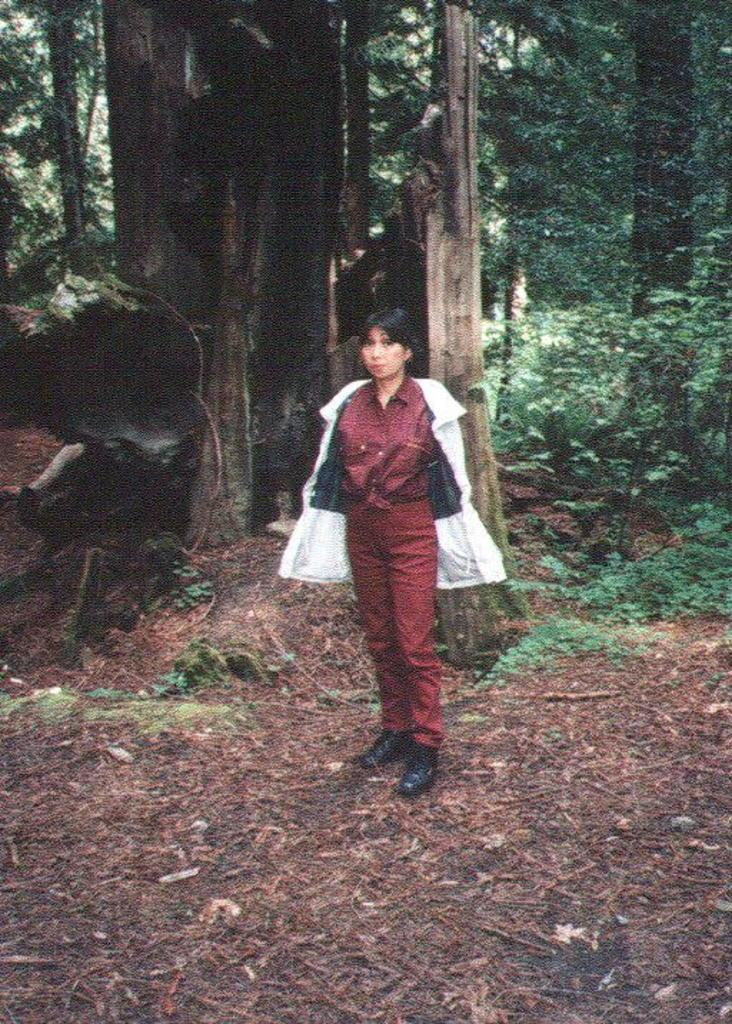Who is present in the image? There is a woman in the image. What is the woman's position in the image? The woman is standing on the ground. What can be seen in the background of the image? There are trees and plants in the background of the image. How many chairs are visible in the image? There are no chairs present in the image. What type of glove is the woman wearing in the image? The woman is not wearing a glove in the image. 